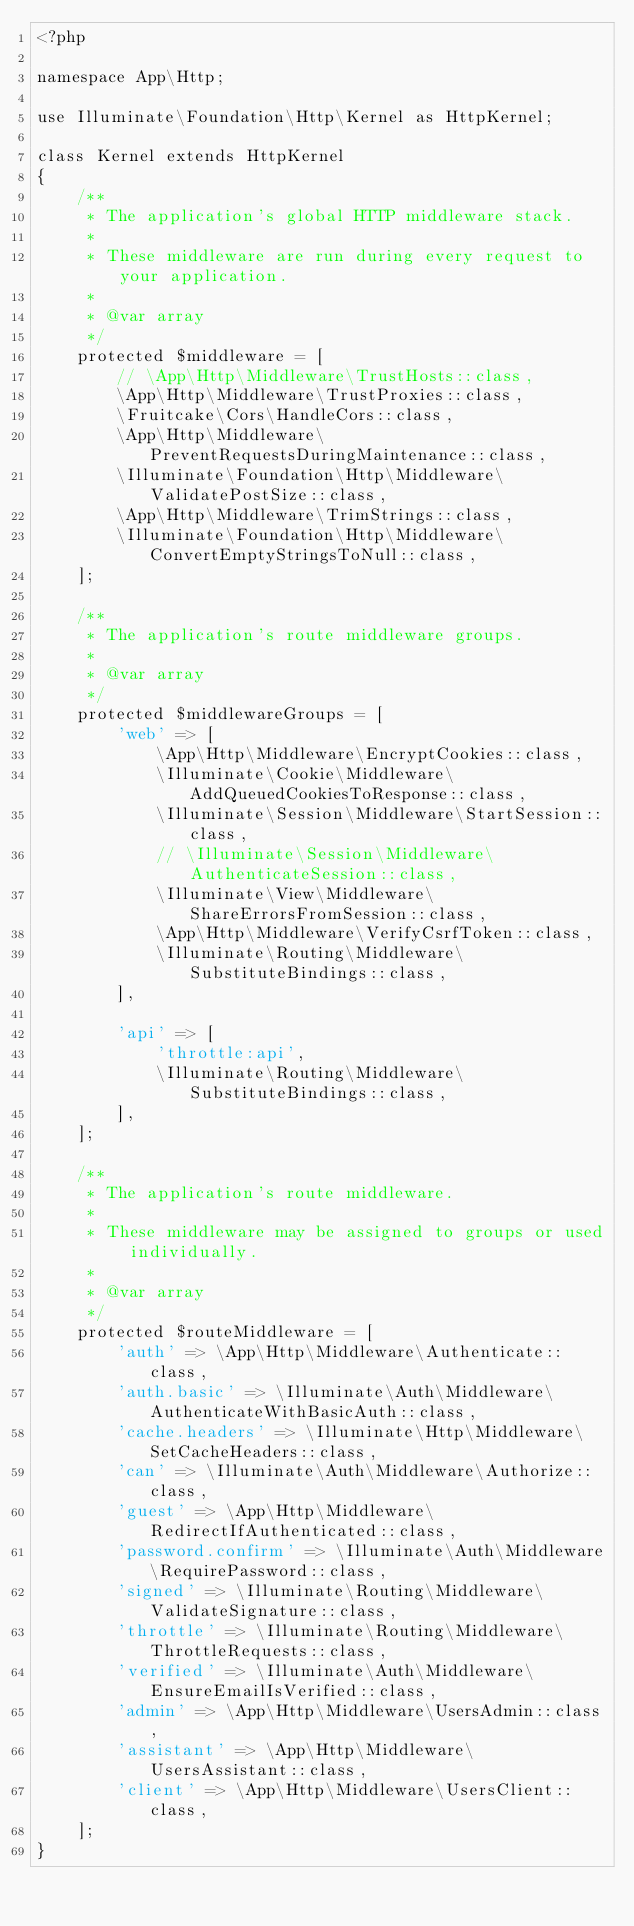<code> <loc_0><loc_0><loc_500><loc_500><_PHP_><?php

namespace App\Http;

use Illuminate\Foundation\Http\Kernel as HttpKernel;

class Kernel extends HttpKernel
{
    /**
     * The application's global HTTP middleware stack.
     *
     * These middleware are run during every request to your application.
     *
     * @var array
     */
    protected $middleware = [
        // \App\Http\Middleware\TrustHosts::class,
        \App\Http\Middleware\TrustProxies::class,
        \Fruitcake\Cors\HandleCors::class,
        \App\Http\Middleware\PreventRequestsDuringMaintenance::class,
        \Illuminate\Foundation\Http\Middleware\ValidatePostSize::class,
        \App\Http\Middleware\TrimStrings::class,
        \Illuminate\Foundation\Http\Middleware\ConvertEmptyStringsToNull::class,
    ];

    /**
     * The application's route middleware groups.
     *
     * @var array
     */
    protected $middlewareGroups = [
        'web' => [
            \App\Http\Middleware\EncryptCookies::class,
            \Illuminate\Cookie\Middleware\AddQueuedCookiesToResponse::class,
            \Illuminate\Session\Middleware\StartSession::class,
            // \Illuminate\Session\Middleware\AuthenticateSession::class,
            \Illuminate\View\Middleware\ShareErrorsFromSession::class,
            \App\Http\Middleware\VerifyCsrfToken::class,
            \Illuminate\Routing\Middleware\SubstituteBindings::class,
        ],

        'api' => [
            'throttle:api',
            \Illuminate\Routing\Middleware\SubstituteBindings::class,
        ],
    ];

    /**
     * The application's route middleware.
     *
     * These middleware may be assigned to groups or used individually.
     *
     * @var array
     */
    protected $routeMiddleware = [
        'auth' => \App\Http\Middleware\Authenticate::class,
        'auth.basic' => \Illuminate\Auth\Middleware\AuthenticateWithBasicAuth::class,
        'cache.headers' => \Illuminate\Http\Middleware\SetCacheHeaders::class,
        'can' => \Illuminate\Auth\Middleware\Authorize::class,
        'guest' => \App\Http\Middleware\RedirectIfAuthenticated::class,
        'password.confirm' => \Illuminate\Auth\Middleware\RequirePassword::class,
        'signed' => \Illuminate\Routing\Middleware\ValidateSignature::class,
        'throttle' => \Illuminate\Routing\Middleware\ThrottleRequests::class,
        'verified' => \Illuminate\Auth\Middleware\EnsureEmailIsVerified::class,
        'admin' => \App\Http\Middleware\UsersAdmin::class,
        'assistant' => \App\Http\Middleware\UsersAssistant::class,
        'client' => \App\Http\Middleware\UsersClient::class,
    ];
}
</code> 